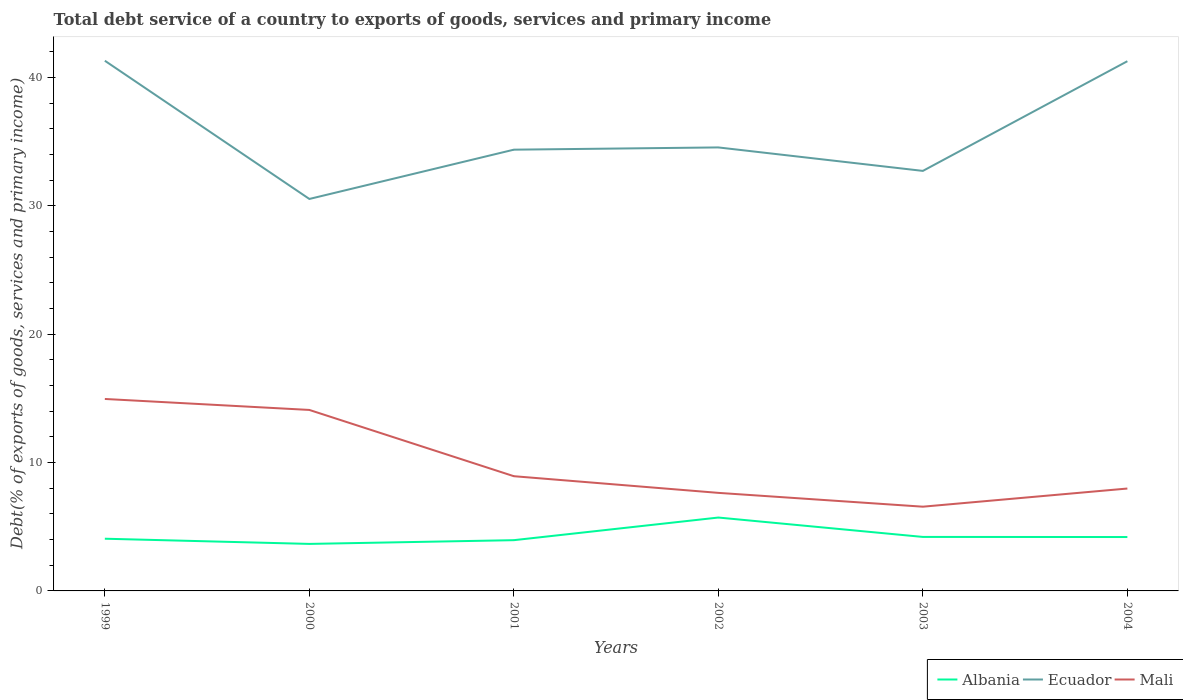How many different coloured lines are there?
Make the answer very short. 3. Is the number of lines equal to the number of legend labels?
Ensure brevity in your answer.  Yes. Across all years, what is the maximum total debt service in Albania?
Ensure brevity in your answer.  3.66. What is the total total debt service in Albania in the graph?
Keep it short and to the point. 1.52. What is the difference between the highest and the second highest total debt service in Mali?
Your answer should be very brief. 8.39. Is the total debt service in Ecuador strictly greater than the total debt service in Mali over the years?
Ensure brevity in your answer.  No. How many years are there in the graph?
Provide a succinct answer. 6. What is the difference between two consecutive major ticks on the Y-axis?
Offer a terse response. 10. Are the values on the major ticks of Y-axis written in scientific E-notation?
Make the answer very short. No. Does the graph contain any zero values?
Provide a succinct answer. No. Does the graph contain grids?
Your answer should be compact. No. Where does the legend appear in the graph?
Your answer should be compact. Bottom right. How many legend labels are there?
Keep it short and to the point. 3. How are the legend labels stacked?
Provide a succinct answer. Horizontal. What is the title of the graph?
Make the answer very short. Total debt service of a country to exports of goods, services and primary income. Does "United Kingdom" appear as one of the legend labels in the graph?
Offer a terse response. No. What is the label or title of the X-axis?
Make the answer very short. Years. What is the label or title of the Y-axis?
Provide a short and direct response. Debt(% of exports of goods, services and primary income). What is the Debt(% of exports of goods, services and primary income) in Albania in 1999?
Your answer should be very brief. 4.07. What is the Debt(% of exports of goods, services and primary income) in Ecuador in 1999?
Make the answer very short. 41.31. What is the Debt(% of exports of goods, services and primary income) in Mali in 1999?
Provide a succinct answer. 14.96. What is the Debt(% of exports of goods, services and primary income) of Albania in 2000?
Your answer should be compact. 3.66. What is the Debt(% of exports of goods, services and primary income) of Ecuador in 2000?
Keep it short and to the point. 30.54. What is the Debt(% of exports of goods, services and primary income) in Mali in 2000?
Provide a short and direct response. 14.1. What is the Debt(% of exports of goods, services and primary income) in Albania in 2001?
Give a very brief answer. 3.95. What is the Debt(% of exports of goods, services and primary income) in Ecuador in 2001?
Offer a terse response. 34.38. What is the Debt(% of exports of goods, services and primary income) in Mali in 2001?
Provide a short and direct response. 8.94. What is the Debt(% of exports of goods, services and primary income) of Albania in 2002?
Offer a very short reply. 5.72. What is the Debt(% of exports of goods, services and primary income) in Ecuador in 2002?
Offer a very short reply. 34.56. What is the Debt(% of exports of goods, services and primary income) in Mali in 2002?
Provide a succinct answer. 7.64. What is the Debt(% of exports of goods, services and primary income) of Albania in 2003?
Ensure brevity in your answer.  4.21. What is the Debt(% of exports of goods, services and primary income) in Ecuador in 2003?
Keep it short and to the point. 32.73. What is the Debt(% of exports of goods, services and primary income) of Mali in 2003?
Offer a terse response. 6.56. What is the Debt(% of exports of goods, services and primary income) of Albania in 2004?
Provide a succinct answer. 4.2. What is the Debt(% of exports of goods, services and primary income) of Ecuador in 2004?
Ensure brevity in your answer.  41.27. What is the Debt(% of exports of goods, services and primary income) of Mali in 2004?
Ensure brevity in your answer.  7.98. Across all years, what is the maximum Debt(% of exports of goods, services and primary income) of Albania?
Make the answer very short. 5.72. Across all years, what is the maximum Debt(% of exports of goods, services and primary income) of Ecuador?
Make the answer very short. 41.31. Across all years, what is the maximum Debt(% of exports of goods, services and primary income) in Mali?
Keep it short and to the point. 14.96. Across all years, what is the minimum Debt(% of exports of goods, services and primary income) in Albania?
Give a very brief answer. 3.66. Across all years, what is the minimum Debt(% of exports of goods, services and primary income) in Ecuador?
Provide a short and direct response. 30.54. Across all years, what is the minimum Debt(% of exports of goods, services and primary income) in Mali?
Provide a succinct answer. 6.56. What is the total Debt(% of exports of goods, services and primary income) of Albania in the graph?
Your answer should be very brief. 25.81. What is the total Debt(% of exports of goods, services and primary income) of Ecuador in the graph?
Your answer should be very brief. 214.79. What is the total Debt(% of exports of goods, services and primary income) in Mali in the graph?
Make the answer very short. 60.18. What is the difference between the Debt(% of exports of goods, services and primary income) of Albania in 1999 and that in 2000?
Provide a short and direct response. 0.4. What is the difference between the Debt(% of exports of goods, services and primary income) of Ecuador in 1999 and that in 2000?
Keep it short and to the point. 10.77. What is the difference between the Debt(% of exports of goods, services and primary income) in Mali in 1999 and that in 2000?
Your answer should be compact. 0.86. What is the difference between the Debt(% of exports of goods, services and primary income) of Albania in 1999 and that in 2001?
Give a very brief answer. 0.11. What is the difference between the Debt(% of exports of goods, services and primary income) in Ecuador in 1999 and that in 2001?
Make the answer very short. 6.93. What is the difference between the Debt(% of exports of goods, services and primary income) in Mali in 1999 and that in 2001?
Your answer should be compact. 6.02. What is the difference between the Debt(% of exports of goods, services and primary income) in Albania in 1999 and that in 2002?
Your answer should be compact. -1.65. What is the difference between the Debt(% of exports of goods, services and primary income) in Ecuador in 1999 and that in 2002?
Provide a short and direct response. 6.75. What is the difference between the Debt(% of exports of goods, services and primary income) in Mali in 1999 and that in 2002?
Your answer should be very brief. 7.32. What is the difference between the Debt(% of exports of goods, services and primary income) in Albania in 1999 and that in 2003?
Provide a succinct answer. -0.14. What is the difference between the Debt(% of exports of goods, services and primary income) of Ecuador in 1999 and that in 2003?
Make the answer very short. 8.58. What is the difference between the Debt(% of exports of goods, services and primary income) in Mali in 1999 and that in 2003?
Offer a terse response. 8.39. What is the difference between the Debt(% of exports of goods, services and primary income) of Albania in 1999 and that in 2004?
Provide a succinct answer. -0.13. What is the difference between the Debt(% of exports of goods, services and primary income) of Ecuador in 1999 and that in 2004?
Your answer should be very brief. 0.04. What is the difference between the Debt(% of exports of goods, services and primary income) of Mali in 1999 and that in 2004?
Offer a very short reply. 6.98. What is the difference between the Debt(% of exports of goods, services and primary income) in Albania in 2000 and that in 2001?
Provide a succinct answer. -0.29. What is the difference between the Debt(% of exports of goods, services and primary income) of Ecuador in 2000 and that in 2001?
Your answer should be very brief. -3.84. What is the difference between the Debt(% of exports of goods, services and primary income) in Mali in 2000 and that in 2001?
Offer a very short reply. 5.16. What is the difference between the Debt(% of exports of goods, services and primary income) of Albania in 2000 and that in 2002?
Offer a very short reply. -2.05. What is the difference between the Debt(% of exports of goods, services and primary income) of Ecuador in 2000 and that in 2002?
Make the answer very short. -4.02. What is the difference between the Debt(% of exports of goods, services and primary income) of Mali in 2000 and that in 2002?
Your answer should be compact. 6.46. What is the difference between the Debt(% of exports of goods, services and primary income) in Albania in 2000 and that in 2003?
Your answer should be very brief. -0.54. What is the difference between the Debt(% of exports of goods, services and primary income) in Ecuador in 2000 and that in 2003?
Your response must be concise. -2.19. What is the difference between the Debt(% of exports of goods, services and primary income) of Mali in 2000 and that in 2003?
Provide a short and direct response. 7.54. What is the difference between the Debt(% of exports of goods, services and primary income) of Albania in 2000 and that in 2004?
Offer a terse response. -0.54. What is the difference between the Debt(% of exports of goods, services and primary income) in Ecuador in 2000 and that in 2004?
Make the answer very short. -10.73. What is the difference between the Debt(% of exports of goods, services and primary income) of Mali in 2000 and that in 2004?
Provide a short and direct response. 6.12. What is the difference between the Debt(% of exports of goods, services and primary income) in Albania in 2001 and that in 2002?
Ensure brevity in your answer.  -1.76. What is the difference between the Debt(% of exports of goods, services and primary income) in Ecuador in 2001 and that in 2002?
Keep it short and to the point. -0.18. What is the difference between the Debt(% of exports of goods, services and primary income) in Mali in 2001 and that in 2002?
Give a very brief answer. 1.3. What is the difference between the Debt(% of exports of goods, services and primary income) of Albania in 2001 and that in 2003?
Offer a terse response. -0.25. What is the difference between the Debt(% of exports of goods, services and primary income) in Ecuador in 2001 and that in 2003?
Give a very brief answer. 1.65. What is the difference between the Debt(% of exports of goods, services and primary income) in Mali in 2001 and that in 2003?
Give a very brief answer. 2.38. What is the difference between the Debt(% of exports of goods, services and primary income) in Albania in 2001 and that in 2004?
Offer a very short reply. -0.24. What is the difference between the Debt(% of exports of goods, services and primary income) of Ecuador in 2001 and that in 2004?
Keep it short and to the point. -6.89. What is the difference between the Debt(% of exports of goods, services and primary income) of Mali in 2001 and that in 2004?
Your answer should be very brief. 0.96. What is the difference between the Debt(% of exports of goods, services and primary income) of Albania in 2002 and that in 2003?
Give a very brief answer. 1.51. What is the difference between the Debt(% of exports of goods, services and primary income) in Ecuador in 2002 and that in 2003?
Give a very brief answer. 1.83. What is the difference between the Debt(% of exports of goods, services and primary income) in Mali in 2002 and that in 2003?
Offer a very short reply. 1.08. What is the difference between the Debt(% of exports of goods, services and primary income) in Albania in 2002 and that in 2004?
Offer a very short reply. 1.52. What is the difference between the Debt(% of exports of goods, services and primary income) in Ecuador in 2002 and that in 2004?
Offer a very short reply. -6.72. What is the difference between the Debt(% of exports of goods, services and primary income) in Mali in 2002 and that in 2004?
Ensure brevity in your answer.  -0.34. What is the difference between the Debt(% of exports of goods, services and primary income) in Albania in 2003 and that in 2004?
Offer a terse response. 0.01. What is the difference between the Debt(% of exports of goods, services and primary income) of Ecuador in 2003 and that in 2004?
Offer a very short reply. -8.55. What is the difference between the Debt(% of exports of goods, services and primary income) of Mali in 2003 and that in 2004?
Ensure brevity in your answer.  -1.42. What is the difference between the Debt(% of exports of goods, services and primary income) of Albania in 1999 and the Debt(% of exports of goods, services and primary income) of Ecuador in 2000?
Your answer should be compact. -26.47. What is the difference between the Debt(% of exports of goods, services and primary income) in Albania in 1999 and the Debt(% of exports of goods, services and primary income) in Mali in 2000?
Offer a very short reply. -10.03. What is the difference between the Debt(% of exports of goods, services and primary income) of Ecuador in 1999 and the Debt(% of exports of goods, services and primary income) of Mali in 2000?
Make the answer very short. 27.21. What is the difference between the Debt(% of exports of goods, services and primary income) of Albania in 1999 and the Debt(% of exports of goods, services and primary income) of Ecuador in 2001?
Provide a succinct answer. -30.31. What is the difference between the Debt(% of exports of goods, services and primary income) of Albania in 1999 and the Debt(% of exports of goods, services and primary income) of Mali in 2001?
Ensure brevity in your answer.  -4.87. What is the difference between the Debt(% of exports of goods, services and primary income) in Ecuador in 1999 and the Debt(% of exports of goods, services and primary income) in Mali in 2001?
Provide a short and direct response. 32.37. What is the difference between the Debt(% of exports of goods, services and primary income) of Albania in 1999 and the Debt(% of exports of goods, services and primary income) of Ecuador in 2002?
Your answer should be compact. -30.49. What is the difference between the Debt(% of exports of goods, services and primary income) of Albania in 1999 and the Debt(% of exports of goods, services and primary income) of Mali in 2002?
Make the answer very short. -3.57. What is the difference between the Debt(% of exports of goods, services and primary income) in Ecuador in 1999 and the Debt(% of exports of goods, services and primary income) in Mali in 2002?
Ensure brevity in your answer.  33.67. What is the difference between the Debt(% of exports of goods, services and primary income) in Albania in 1999 and the Debt(% of exports of goods, services and primary income) in Ecuador in 2003?
Give a very brief answer. -28.66. What is the difference between the Debt(% of exports of goods, services and primary income) of Albania in 1999 and the Debt(% of exports of goods, services and primary income) of Mali in 2003?
Your response must be concise. -2.5. What is the difference between the Debt(% of exports of goods, services and primary income) of Ecuador in 1999 and the Debt(% of exports of goods, services and primary income) of Mali in 2003?
Keep it short and to the point. 34.75. What is the difference between the Debt(% of exports of goods, services and primary income) in Albania in 1999 and the Debt(% of exports of goods, services and primary income) in Ecuador in 2004?
Give a very brief answer. -37.21. What is the difference between the Debt(% of exports of goods, services and primary income) in Albania in 1999 and the Debt(% of exports of goods, services and primary income) in Mali in 2004?
Ensure brevity in your answer.  -3.91. What is the difference between the Debt(% of exports of goods, services and primary income) of Ecuador in 1999 and the Debt(% of exports of goods, services and primary income) of Mali in 2004?
Offer a very short reply. 33.33. What is the difference between the Debt(% of exports of goods, services and primary income) in Albania in 2000 and the Debt(% of exports of goods, services and primary income) in Ecuador in 2001?
Your answer should be very brief. -30.72. What is the difference between the Debt(% of exports of goods, services and primary income) in Albania in 2000 and the Debt(% of exports of goods, services and primary income) in Mali in 2001?
Keep it short and to the point. -5.28. What is the difference between the Debt(% of exports of goods, services and primary income) in Ecuador in 2000 and the Debt(% of exports of goods, services and primary income) in Mali in 2001?
Provide a short and direct response. 21.6. What is the difference between the Debt(% of exports of goods, services and primary income) of Albania in 2000 and the Debt(% of exports of goods, services and primary income) of Ecuador in 2002?
Provide a short and direct response. -30.89. What is the difference between the Debt(% of exports of goods, services and primary income) in Albania in 2000 and the Debt(% of exports of goods, services and primary income) in Mali in 2002?
Provide a succinct answer. -3.98. What is the difference between the Debt(% of exports of goods, services and primary income) in Ecuador in 2000 and the Debt(% of exports of goods, services and primary income) in Mali in 2002?
Provide a short and direct response. 22.9. What is the difference between the Debt(% of exports of goods, services and primary income) of Albania in 2000 and the Debt(% of exports of goods, services and primary income) of Ecuador in 2003?
Your answer should be compact. -29.06. What is the difference between the Debt(% of exports of goods, services and primary income) in Albania in 2000 and the Debt(% of exports of goods, services and primary income) in Mali in 2003?
Provide a short and direct response. -2.9. What is the difference between the Debt(% of exports of goods, services and primary income) of Ecuador in 2000 and the Debt(% of exports of goods, services and primary income) of Mali in 2003?
Keep it short and to the point. 23.98. What is the difference between the Debt(% of exports of goods, services and primary income) in Albania in 2000 and the Debt(% of exports of goods, services and primary income) in Ecuador in 2004?
Your response must be concise. -37.61. What is the difference between the Debt(% of exports of goods, services and primary income) of Albania in 2000 and the Debt(% of exports of goods, services and primary income) of Mali in 2004?
Keep it short and to the point. -4.31. What is the difference between the Debt(% of exports of goods, services and primary income) of Ecuador in 2000 and the Debt(% of exports of goods, services and primary income) of Mali in 2004?
Ensure brevity in your answer.  22.56. What is the difference between the Debt(% of exports of goods, services and primary income) of Albania in 2001 and the Debt(% of exports of goods, services and primary income) of Ecuador in 2002?
Your answer should be very brief. -30.6. What is the difference between the Debt(% of exports of goods, services and primary income) of Albania in 2001 and the Debt(% of exports of goods, services and primary income) of Mali in 2002?
Offer a terse response. -3.69. What is the difference between the Debt(% of exports of goods, services and primary income) of Ecuador in 2001 and the Debt(% of exports of goods, services and primary income) of Mali in 2002?
Keep it short and to the point. 26.74. What is the difference between the Debt(% of exports of goods, services and primary income) of Albania in 2001 and the Debt(% of exports of goods, services and primary income) of Ecuador in 2003?
Offer a very short reply. -28.77. What is the difference between the Debt(% of exports of goods, services and primary income) of Albania in 2001 and the Debt(% of exports of goods, services and primary income) of Mali in 2003?
Provide a succinct answer. -2.61. What is the difference between the Debt(% of exports of goods, services and primary income) in Ecuador in 2001 and the Debt(% of exports of goods, services and primary income) in Mali in 2003?
Provide a short and direct response. 27.82. What is the difference between the Debt(% of exports of goods, services and primary income) in Albania in 2001 and the Debt(% of exports of goods, services and primary income) in Ecuador in 2004?
Offer a very short reply. -37.32. What is the difference between the Debt(% of exports of goods, services and primary income) of Albania in 2001 and the Debt(% of exports of goods, services and primary income) of Mali in 2004?
Give a very brief answer. -4.02. What is the difference between the Debt(% of exports of goods, services and primary income) in Ecuador in 2001 and the Debt(% of exports of goods, services and primary income) in Mali in 2004?
Provide a succinct answer. 26.4. What is the difference between the Debt(% of exports of goods, services and primary income) in Albania in 2002 and the Debt(% of exports of goods, services and primary income) in Ecuador in 2003?
Your answer should be very brief. -27.01. What is the difference between the Debt(% of exports of goods, services and primary income) of Albania in 2002 and the Debt(% of exports of goods, services and primary income) of Mali in 2003?
Your answer should be very brief. -0.85. What is the difference between the Debt(% of exports of goods, services and primary income) of Ecuador in 2002 and the Debt(% of exports of goods, services and primary income) of Mali in 2003?
Your response must be concise. 27.99. What is the difference between the Debt(% of exports of goods, services and primary income) of Albania in 2002 and the Debt(% of exports of goods, services and primary income) of Ecuador in 2004?
Offer a terse response. -35.56. What is the difference between the Debt(% of exports of goods, services and primary income) of Albania in 2002 and the Debt(% of exports of goods, services and primary income) of Mali in 2004?
Your answer should be very brief. -2.26. What is the difference between the Debt(% of exports of goods, services and primary income) in Ecuador in 2002 and the Debt(% of exports of goods, services and primary income) in Mali in 2004?
Ensure brevity in your answer.  26.58. What is the difference between the Debt(% of exports of goods, services and primary income) of Albania in 2003 and the Debt(% of exports of goods, services and primary income) of Ecuador in 2004?
Make the answer very short. -37.07. What is the difference between the Debt(% of exports of goods, services and primary income) in Albania in 2003 and the Debt(% of exports of goods, services and primary income) in Mali in 2004?
Make the answer very short. -3.77. What is the difference between the Debt(% of exports of goods, services and primary income) of Ecuador in 2003 and the Debt(% of exports of goods, services and primary income) of Mali in 2004?
Keep it short and to the point. 24.75. What is the average Debt(% of exports of goods, services and primary income) of Albania per year?
Ensure brevity in your answer.  4.3. What is the average Debt(% of exports of goods, services and primary income) of Ecuador per year?
Offer a very short reply. 35.8. What is the average Debt(% of exports of goods, services and primary income) of Mali per year?
Your answer should be very brief. 10.03. In the year 1999, what is the difference between the Debt(% of exports of goods, services and primary income) in Albania and Debt(% of exports of goods, services and primary income) in Ecuador?
Keep it short and to the point. -37.24. In the year 1999, what is the difference between the Debt(% of exports of goods, services and primary income) of Albania and Debt(% of exports of goods, services and primary income) of Mali?
Offer a terse response. -10.89. In the year 1999, what is the difference between the Debt(% of exports of goods, services and primary income) in Ecuador and Debt(% of exports of goods, services and primary income) in Mali?
Ensure brevity in your answer.  26.35. In the year 2000, what is the difference between the Debt(% of exports of goods, services and primary income) in Albania and Debt(% of exports of goods, services and primary income) in Ecuador?
Ensure brevity in your answer.  -26.88. In the year 2000, what is the difference between the Debt(% of exports of goods, services and primary income) of Albania and Debt(% of exports of goods, services and primary income) of Mali?
Your answer should be very brief. -10.44. In the year 2000, what is the difference between the Debt(% of exports of goods, services and primary income) of Ecuador and Debt(% of exports of goods, services and primary income) of Mali?
Provide a succinct answer. 16.44. In the year 2001, what is the difference between the Debt(% of exports of goods, services and primary income) in Albania and Debt(% of exports of goods, services and primary income) in Ecuador?
Your answer should be compact. -30.43. In the year 2001, what is the difference between the Debt(% of exports of goods, services and primary income) in Albania and Debt(% of exports of goods, services and primary income) in Mali?
Give a very brief answer. -4.98. In the year 2001, what is the difference between the Debt(% of exports of goods, services and primary income) of Ecuador and Debt(% of exports of goods, services and primary income) of Mali?
Make the answer very short. 25.44. In the year 2002, what is the difference between the Debt(% of exports of goods, services and primary income) of Albania and Debt(% of exports of goods, services and primary income) of Ecuador?
Your answer should be very brief. -28.84. In the year 2002, what is the difference between the Debt(% of exports of goods, services and primary income) of Albania and Debt(% of exports of goods, services and primary income) of Mali?
Give a very brief answer. -1.92. In the year 2002, what is the difference between the Debt(% of exports of goods, services and primary income) in Ecuador and Debt(% of exports of goods, services and primary income) in Mali?
Make the answer very short. 26.92. In the year 2003, what is the difference between the Debt(% of exports of goods, services and primary income) of Albania and Debt(% of exports of goods, services and primary income) of Ecuador?
Your response must be concise. -28.52. In the year 2003, what is the difference between the Debt(% of exports of goods, services and primary income) of Albania and Debt(% of exports of goods, services and primary income) of Mali?
Provide a short and direct response. -2.36. In the year 2003, what is the difference between the Debt(% of exports of goods, services and primary income) of Ecuador and Debt(% of exports of goods, services and primary income) of Mali?
Your answer should be very brief. 26.16. In the year 2004, what is the difference between the Debt(% of exports of goods, services and primary income) in Albania and Debt(% of exports of goods, services and primary income) in Ecuador?
Provide a succinct answer. -37.08. In the year 2004, what is the difference between the Debt(% of exports of goods, services and primary income) of Albania and Debt(% of exports of goods, services and primary income) of Mali?
Offer a terse response. -3.78. In the year 2004, what is the difference between the Debt(% of exports of goods, services and primary income) in Ecuador and Debt(% of exports of goods, services and primary income) in Mali?
Make the answer very short. 33.3. What is the ratio of the Debt(% of exports of goods, services and primary income) in Albania in 1999 to that in 2000?
Provide a succinct answer. 1.11. What is the ratio of the Debt(% of exports of goods, services and primary income) of Ecuador in 1999 to that in 2000?
Your answer should be compact. 1.35. What is the ratio of the Debt(% of exports of goods, services and primary income) in Mali in 1999 to that in 2000?
Provide a short and direct response. 1.06. What is the ratio of the Debt(% of exports of goods, services and primary income) in Albania in 1999 to that in 2001?
Your response must be concise. 1.03. What is the ratio of the Debt(% of exports of goods, services and primary income) of Ecuador in 1999 to that in 2001?
Provide a short and direct response. 1.2. What is the ratio of the Debt(% of exports of goods, services and primary income) in Mali in 1999 to that in 2001?
Offer a very short reply. 1.67. What is the ratio of the Debt(% of exports of goods, services and primary income) in Albania in 1999 to that in 2002?
Ensure brevity in your answer.  0.71. What is the ratio of the Debt(% of exports of goods, services and primary income) of Ecuador in 1999 to that in 2002?
Your response must be concise. 1.2. What is the ratio of the Debt(% of exports of goods, services and primary income) of Mali in 1999 to that in 2002?
Provide a succinct answer. 1.96. What is the ratio of the Debt(% of exports of goods, services and primary income) in Albania in 1999 to that in 2003?
Provide a short and direct response. 0.97. What is the ratio of the Debt(% of exports of goods, services and primary income) in Ecuador in 1999 to that in 2003?
Your response must be concise. 1.26. What is the ratio of the Debt(% of exports of goods, services and primary income) in Mali in 1999 to that in 2003?
Your answer should be compact. 2.28. What is the ratio of the Debt(% of exports of goods, services and primary income) in Albania in 1999 to that in 2004?
Your answer should be compact. 0.97. What is the ratio of the Debt(% of exports of goods, services and primary income) of Ecuador in 1999 to that in 2004?
Offer a terse response. 1. What is the ratio of the Debt(% of exports of goods, services and primary income) in Mali in 1999 to that in 2004?
Provide a short and direct response. 1.87. What is the ratio of the Debt(% of exports of goods, services and primary income) of Albania in 2000 to that in 2001?
Make the answer very short. 0.93. What is the ratio of the Debt(% of exports of goods, services and primary income) in Ecuador in 2000 to that in 2001?
Provide a short and direct response. 0.89. What is the ratio of the Debt(% of exports of goods, services and primary income) in Mali in 2000 to that in 2001?
Offer a very short reply. 1.58. What is the ratio of the Debt(% of exports of goods, services and primary income) of Albania in 2000 to that in 2002?
Your answer should be compact. 0.64. What is the ratio of the Debt(% of exports of goods, services and primary income) in Ecuador in 2000 to that in 2002?
Make the answer very short. 0.88. What is the ratio of the Debt(% of exports of goods, services and primary income) of Mali in 2000 to that in 2002?
Make the answer very short. 1.85. What is the ratio of the Debt(% of exports of goods, services and primary income) in Albania in 2000 to that in 2003?
Your answer should be very brief. 0.87. What is the ratio of the Debt(% of exports of goods, services and primary income) in Ecuador in 2000 to that in 2003?
Make the answer very short. 0.93. What is the ratio of the Debt(% of exports of goods, services and primary income) in Mali in 2000 to that in 2003?
Make the answer very short. 2.15. What is the ratio of the Debt(% of exports of goods, services and primary income) in Albania in 2000 to that in 2004?
Keep it short and to the point. 0.87. What is the ratio of the Debt(% of exports of goods, services and primary income) in Ecuador in 2000 to that in 2004?
Provide a succinct answer. 0.74. What is the ratio of the Debt(% of exports of goods, services and primary income) in Mali in 2000 to that in 2004?
Your answer should be very brief. 1.77. What is the ratio of the Debt(% of exports of goods, services and primary income) of Albania in 2001 to that in 2002?
Give a very brief answer. 0.69. What is the ratio of the Debt(% of exports of goods, services and primary income) in Mali in 2001 to that in 2002?
Your answer should be compact. 1.17. What is the ratio of the Debt(% of exports of goods, services and primary income) of Albania in 2001 to that in 2003?
Keep it short and to the point. 0.94. What is the ratio of the Debt(% of exports of goods, services and primary income) of Ecuador in 2001 to that in 2003?
Provide a short and direct response. 1.05. What is the ratio of the Debt(% of exports of goods, services and primary income) of Mali in 2001 to that in 2003?
Provide a succinct answer. 1.36. What is the ratio of the Debt(% of exports of goods, services and primary income) in Albania in 2001 to that in 2004?
Provide a short and direct response. 0.94. What is the ratio of the Debt(% of exports of goods, services and primary income) in Ecuador in 2001 to that in 2004?
Provide a succinct answer. 0.83. What is the ratio of the Debt(% of exports of goods, services and primary income) of Mali in 2001 to that in 2004?
Your answer should be very brief. 1.12. What is the ratio of the Debt(% of exports of goods, services and primary income) of Albania in 2002 to that in 2003?
Provide a succinct answer. 1.36. What is the ratio of the Debt(% of exports of goods, services and primary income) in Ecuador in 2002 to that in 2003?
Give a very brief answer. 1.06. What is the ratio of the Debt(% of exports of goods, services and primary income) of Mali in 2002 to that in 2003?
Provide a short and direct response. 1.16. What is the ratio of the Debt(% of exports of goods, services and primary income) in Albania in 2002 to that in 2004?
Provide a succinct answer. 1.36. What is the ratio of the Debt(% of exports of goods, services and primary income) in Ecuador in 2002 to that in 2004?
Offer a very short reply. 0.84. What is the ratio of the Debt(% of exports of goods, services and primary income) of Mali in 2002 to that in 2004?
Your answer should be compact. 0.96. What is the ratio of the Debt(% of exports of goods, services and primary income) in Ecuador in 2003 to that in 2004?
Provide a succinct answer. 0.79. What is the ratio of the Debt(% of exports of goods, services and primary income) in Mali in 2003 to that in 2004?
Ensure brevity in your answer.  0.82. What is the difference between the highest and the second highest Debt(% of exports of goods, services and primary income) in Albania?
Keep it short and to the point. 1.51. What is the difference between the highest and the second highest Debt(% of exports of goods, services and primary income) in Ecuador?
Give a very brief answer. 0.04. What is the difference between the highest and the second highest Debt(% of exports of goods, services and primary income) in Mali?
Make the answer very short. 0.86. What is the difference between the highest and the lowest Debt(% of exports of goods, services and primary income) of Albania?
Give a very brief answer. 2.05. What is the difference between the highest and the lowest Debt(% of exports of goods, services and primary income) of Ecuador?
Make the answer very short. 10.77. What is the difference between the highest and the lowest Debt(% of exports of goods, services and primary income) of Mali?
Your answer should be very brief. 8.39. 